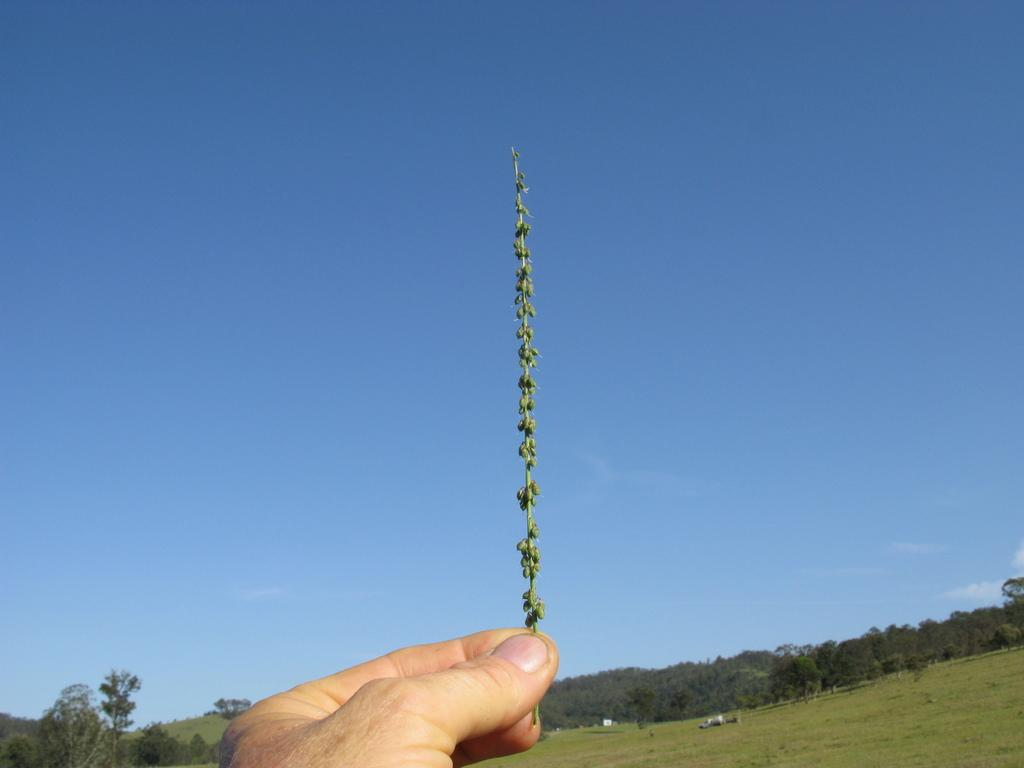What is the person in the image holding? The person is holding a small plant in the image. What type of vegetation can be seen in the image? There are trees in the image. What is on the grass in the image? There are white color objects on the grass. What is visible in the sky in the image? There are clouds in the sky. What is the price of the twig in the image? There is no twig present in the image, and therefore no price can be determined. What letters are visible on the trees in the image? There are no letters visible on the trees in the image; they are natural vegetation. 